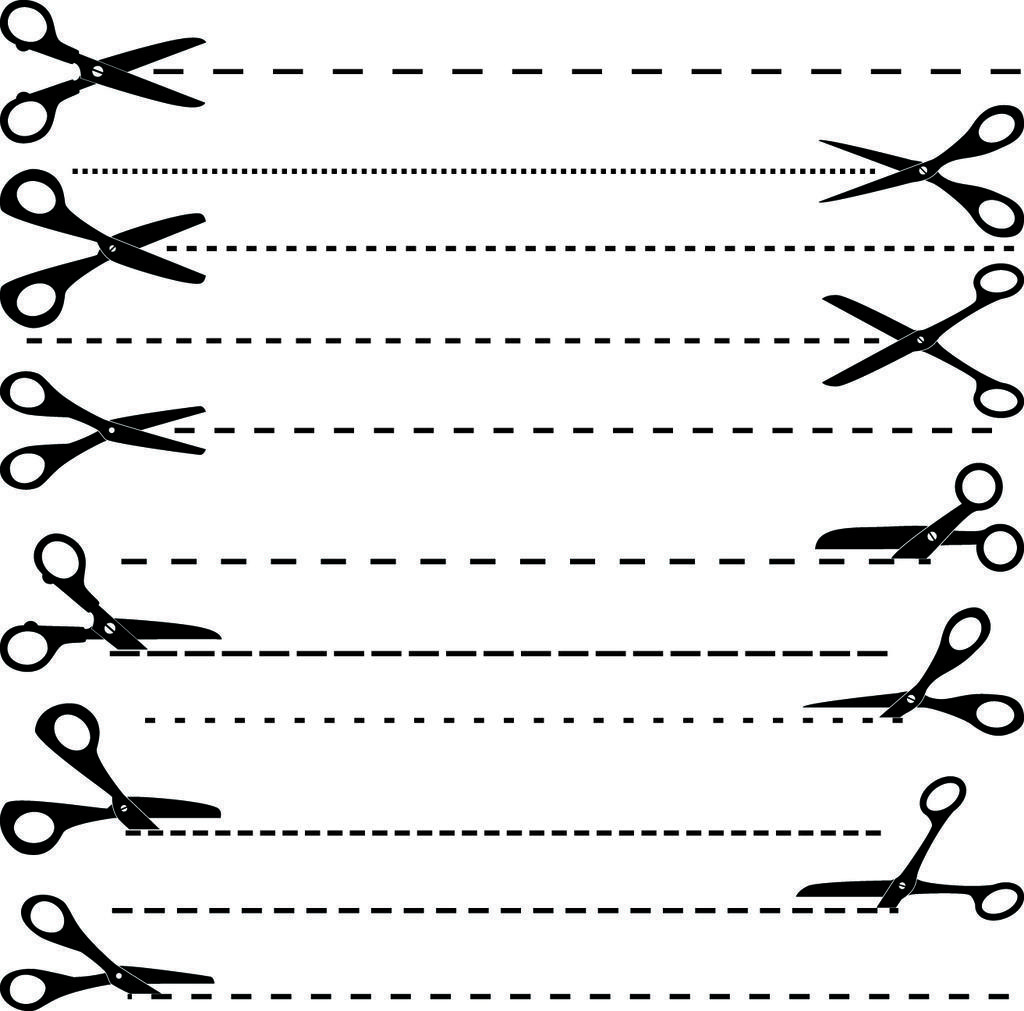Could you give a brief overview of what you see in this image? In this picture I can see a black and white image of scissors and dotted lines. 